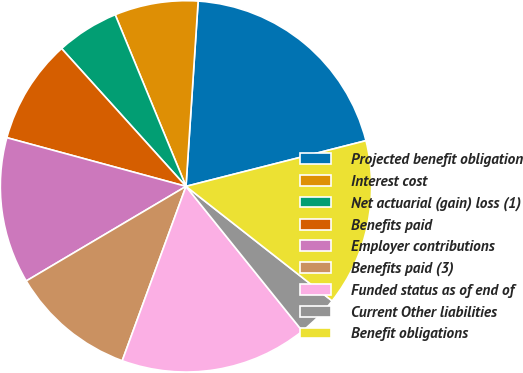Convert chart. <chart><loc_0><loc_0><loc_500><loc_500><pie_chart><fcel>Projected benefit obligation<fcel>Interest cost<fcel>Net actuarial (gain) loss (1)<fcel>Benefits paid<fcel>Employer contributions<fcel>Benefits paid (3)<fcel>Funded status as of end of<fcel>Current Other liabilities<fcel>Benefit obligations<nl><fcel>20.0%<fcel>7.27%<fcel>5.46%<fcel>9.09%<fcel>12.73%<fcel>10.91%<fcel>16.36%<fcel>3.64%<fcel>14.54%<nl></chart> 